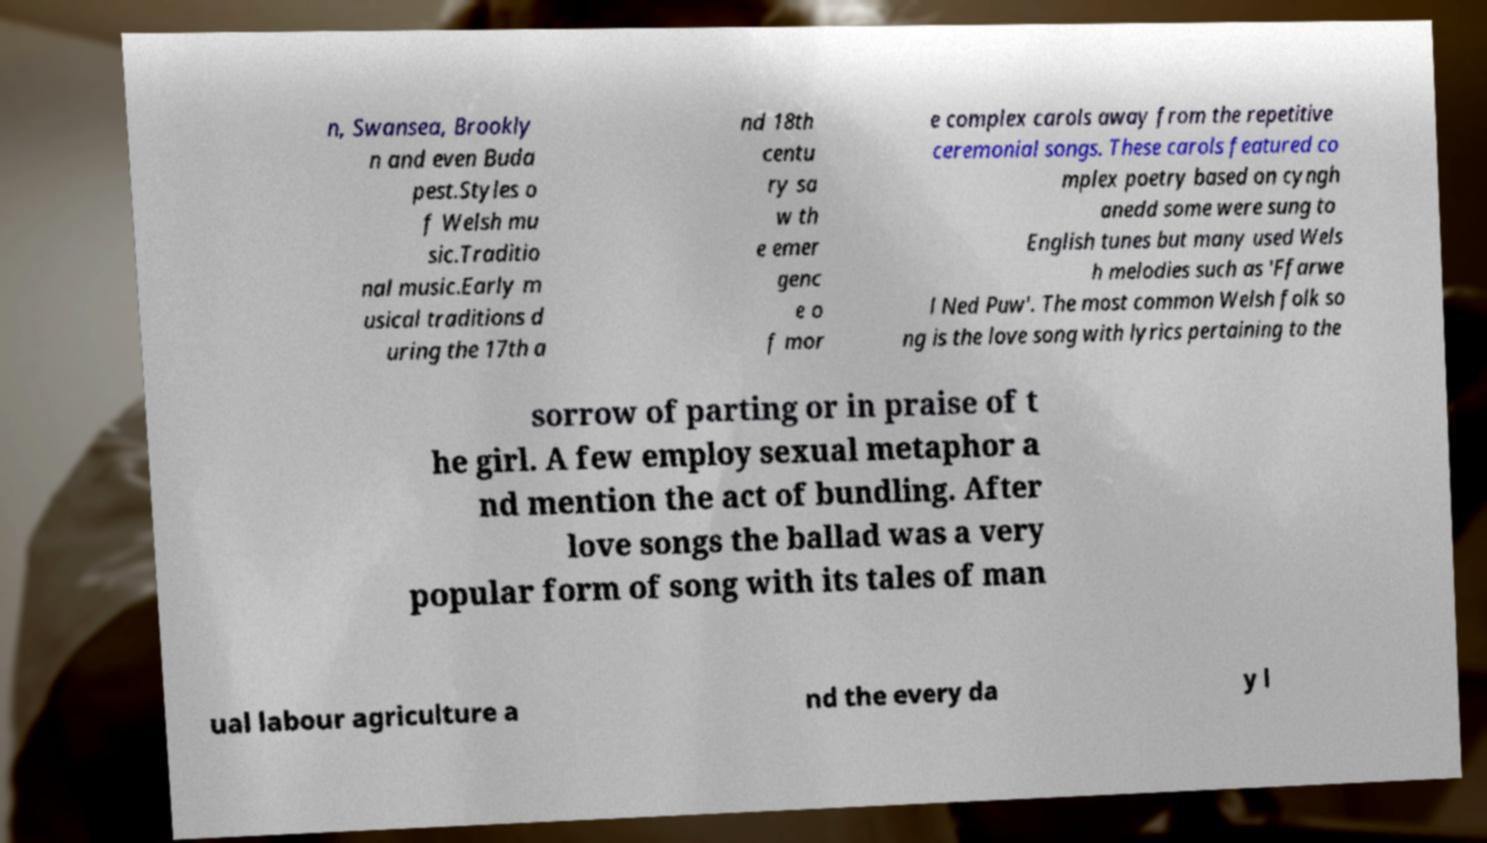Please identify and transcribe the text found in this image. n, Swansea, Brookly n and even Buda pest.Styles o f Welsh mu sic.Traditio nal music.Early m usical traditions d uring the 17th a nd 18th centu ry sa w th e emer genc e o f mor e complex carols away from the repetitive ceremonial songs. These carols featured co mplex poetry based on cyngh anedd some were sung to English tunes but many used Wels h melodies such as 'Ffarwe l Ned Puw'. The most common Welsh folk so ng is the love song with lyrics pertaining to the sorrow of parting or in praise of t he girl. A few employ sexual metaphor a nd mention the act of bundling. After love songs the ballad was a very popular form of song with its tales of man ual labour agriculture a nd the every da y l 